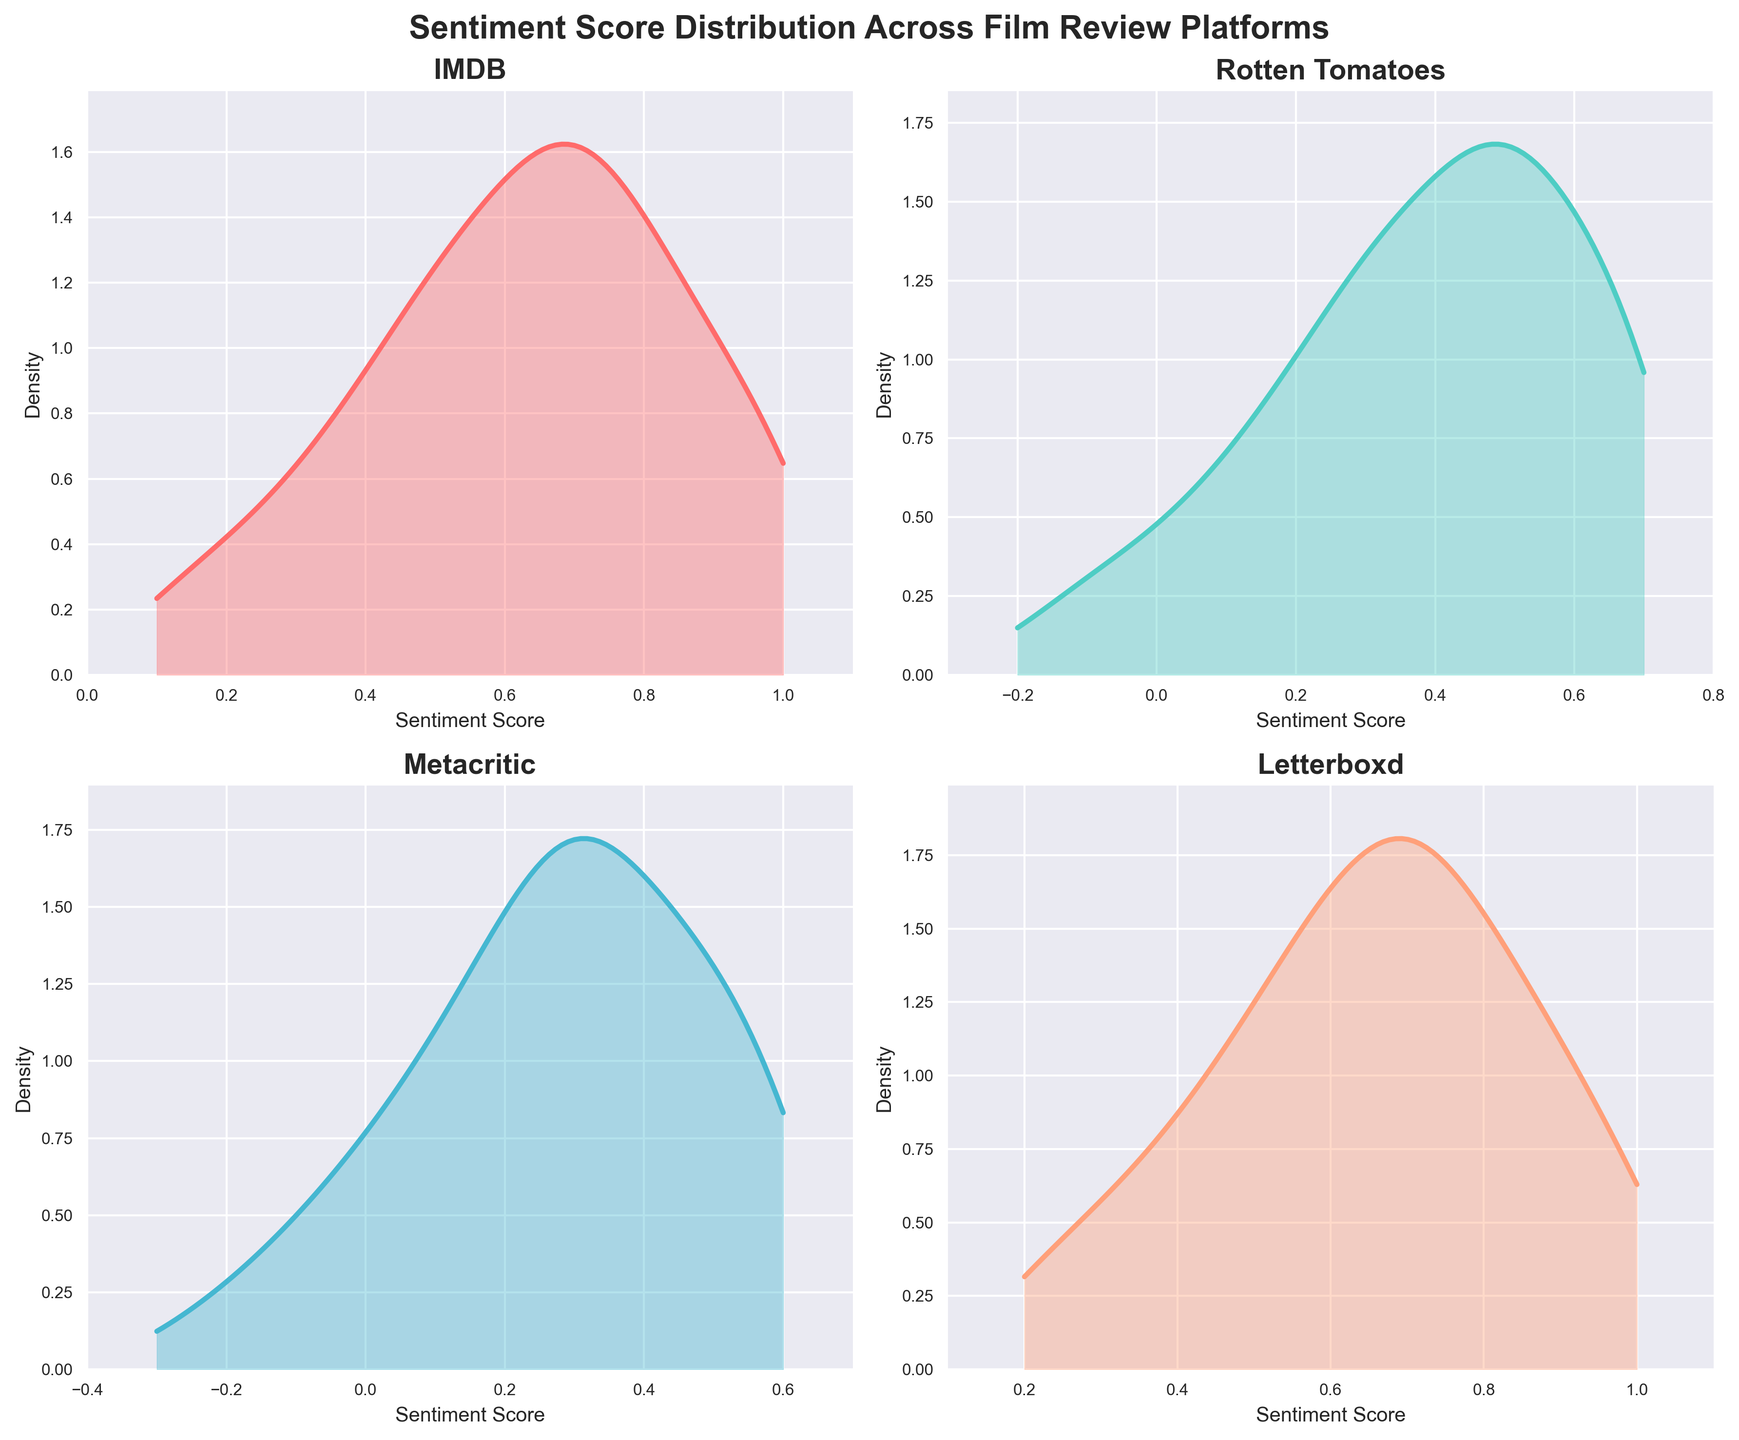What is the title of the plot? The title of the plot is usually found at the top of the figure, and it gives an overview of what the figure represents.
Answer: "Sentiment Score Distribution Across Film Review Platforms" Which platform has the highest density peak for sentiment scores? Look at the density peaks of the plots for each platform. The highest peak represents the platform with the highest density. For IMDB, the peak appears around the score 0.7, for Rotten Tomatoes around 0.5, for Metacritic around 0.3, and for Letterboxd around 0.7.
Answer: Rotten Tomatoes What is the range of sentiment scores for reviews on Metacritic? Review the x-axis (Sentiment Score) for the subplots titled "Metacritic". It starts at -0.3 and ends at 0.6.
Answer: -0.3 to 0.6 Which platform shows the widest range of sentiment scores? Compare the x-axis ranges of the subplots for each platform. IMDB ranges from 0.1 to 1.0, Rotten Tomatoes from -0.2 to 0.7, Metacritic from -0.3 to 0.6, and Letterboxd from 0.2 to 1.0.
Answer: IMDB In which platform's plot does the sentiment score have the most symmetrical distribution? Assess the density plots visually for symmetry across their peaks. A symmetrical distribution will have similar shapes on both sides of the peak. IMDB and Letterboxd show more symmetrical distributions compared to the others.
Answer: Letterboxd How does the density of sentiment scores on Rotten Tomatoes compare to that of Metacritic? Compare the density plots of both Rotten Tomatoes and Metacritic. Rotten Tomatoes shows a high density around 0.5, while Metacritic has a higher density closer to 0.3.
Answer: Rotten Tomatoes has a higher peak density Where do IMDB sentiment scores start to decline in density? Check IMDB's plot for where the density line starts dropping after the peak. This occurs after the 0.7 mark.
Answer: Around 0.7 Which platform shows the lowest density peak? Investigate each density plot to find the subplot with the lowest highest point. IMDB, Rotten Tomatoes, and Letterboxd have relatively high peaks compared to Metacritic.
Answer: Metacritic How is the density distribution of sentiment scores on Letterboxd skewed? Look at the shape of the density plot for Letterboxd. It starts near 0.2 and increases steeply, peaking around 0.7, then dropping slowly, indicating a right skew.
Answer: Right skewed 